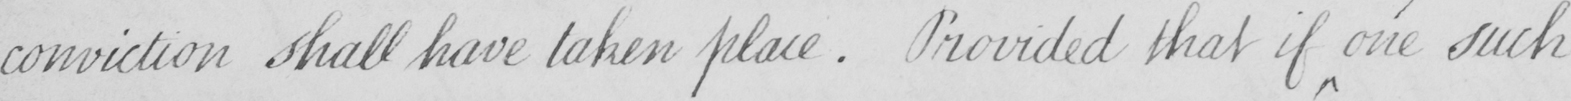What is written in this line of handwriting? conviction shall have taken place . Provided that if one such 